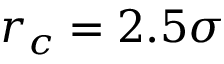<formula> <loc_0><loc_0><loc_500><loc_500>r _ { c } = 2 . 5 \sigma</formula> 